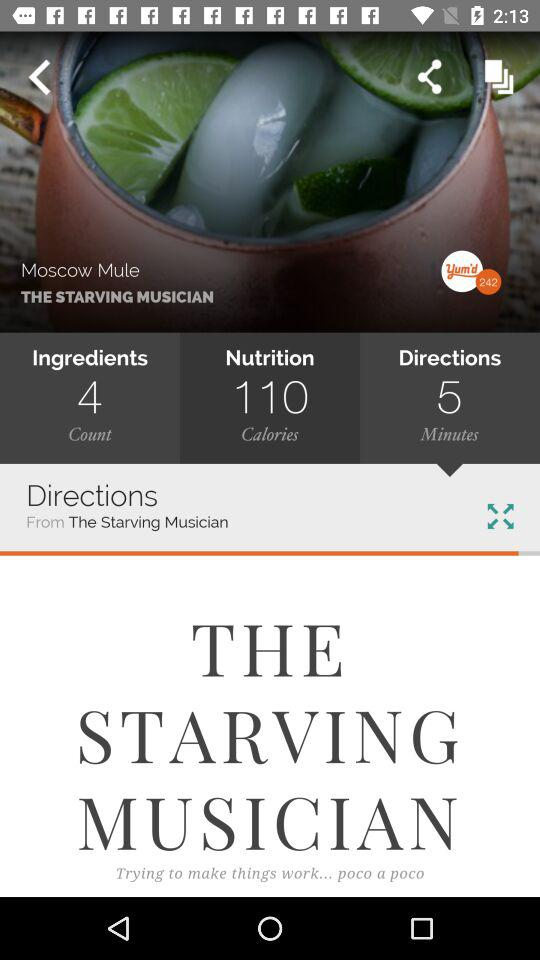How many calories of nutrition are there in "Moscow Mule"? There are 110 calories of nutrition in "Moscow Mule". 